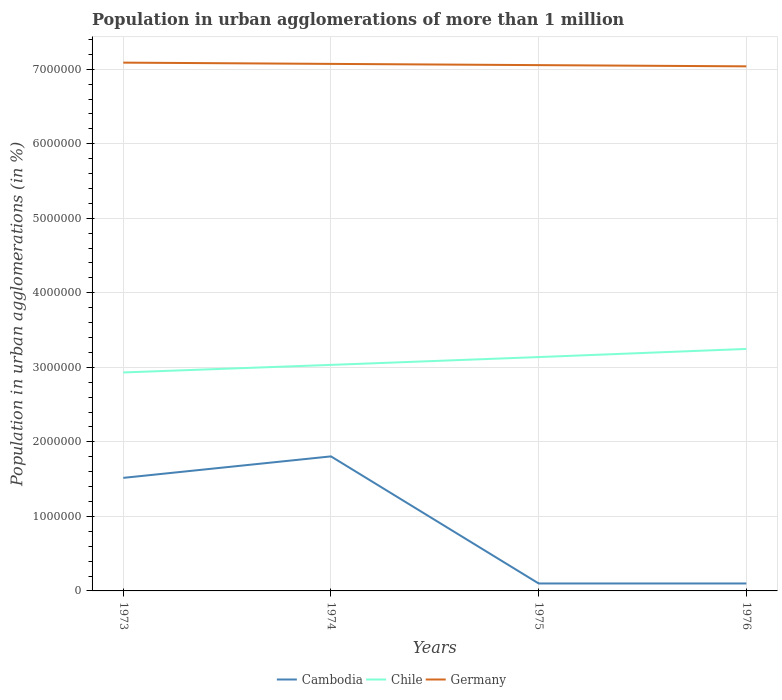How many different coloured lines are there?
Give a very brief answer. 3. Is the number of lines equal to the number of legend labels?
Offer a terse response. Yes. Across all years, what is the maximum population in urban agglomerations in Cambodia?
Your answer should be compact. 1.00e+05. In which year was the population in urban agglomerations in Germany maximum?
Offer a terse response. 1976. What is the total population in urban agglomerations in Germany in the graph?
Make the answer very short. 1.70e+04. What is the difference between the highest and the second highest population in urban agglomerations in Cambodia?
Provide a succinct answer. 1.71e+06. Is the population in urban agglomerations in Cambodia strictly greater than the population in urban agglomerations in Chile over the years?
Provide a short and direct response. Yes. What is the difference between two consecutive major ticks on the Y-axis?
Your answer should be very brief. 1.00e+06. Does the graph contain grids?
Offer a very short reply. Yes. What is the title of the graph?
Your answer should be very brief. Population in urban agglomerations of more than 1 million. What is the label or title of the X-axis?
Offer a terse response. Years. What is the label or title of the Y-axis?
Your response must be concise. Population in urban agglomerations (in %). What is the Population in urban agglomerations (in %) in Cambodia in 1973?
Your answer should be very brief. 1.52e+06. What is the Population in urban agglomerations (in %) of Chile in 1973?
Provide a short and direct response. 2.93e+06. What is the Population in urban agglomerations (in %) in Germany in 1973?
Provide a succinct answer. 7.09e+06. What is the Population in urban agglomerations (in %) of Cambodia in 1974?
Your response must be concise. 1.81e+06. What is the Population in urban agglomerations (in %) in Chile in 1974?
Your response must be concise. 3.03e+06. What is the Population in urban agglomerations (in %) in Germany in 1974?
Offer a very short reply. 7.07e+06. What is the Population in urban agglomerations (in %) in Cambodia in 1975?
Give a very brief answer. 1.00e+05. What is the Population in urban agglomerations (in %) of Chile in 1975?
Provide a short and direct response. 3.14e+06. What is the Population in urban agglomerations (in %) in Germany in 1975?
Keep it short and to the point. 7.05e+06. What is the Population in urban agglomerations (in %) in Cambodia in 1976?
Your answer should be very brief. 1.00e+05. What is the Population in urban agglomerations (in %) in Chile in 1976?
Your answer should be compact. 3.25e+06. What is the Population in urban agglomerations (in %) of Germany in 1976?
Keep it short and to the point. 7.04e+06. Across all years, what is the maximum Population in urban agglomerations (in %) in Cambodia?
Make the answer very short. 1.81e+06. Across all years, what is the maximum Population in urban agglomerations (in %) of Chile?
Give a very brief answer. 3.25e+06. Across all years, what is the maximum Population in urban agglomerations (in %) of Germany?
Make the answer very short. 7.09e+06. Across all years, what is the minimum Population in urban agglomerations (in %) of Chile?
Provide a short and direct response. 2.93e+06. Across all years, what is the minimum Population in urban agglomerations (in %) in Germany?
Your answer should be compact. 7.04e+06. What is the total Population in urban agglomerations (in %) in Cambodia in the graph?
Provide a short and direct response. 3.52e+06. What is the total Population in urban agglomerations (in %) of Chile in the graph?
Make the answer very short. 1.23e+07. What is the total Population in urban agglomerations (in %) of Germany in the graph?
Offer a very short reply. 2.83e+07. What is the difference between the Population in urban agglomerations (in %) of Cambodia in 1973 and that in 1974?
Offer a very short reply. -2.88e+05. What is the difference between the Population in urban agglomerations (in %) of Chile in 1973 and that in 1974?
Offer a terse response. -1.02e+05. What is the difference between the Population in urban agglomerations (in %) of Germany in 1973 and that in 1974?
Offer a terse response. 1.70e+04. What is the difference between the Population in urban agglomerations (in %) in Cambodia in 1973 and that in 1975?
Offer a very short reply. 1.42e+06. What is the difference between the Population in urban agglomerations (in %) in Chile in 1973 and that in 1975?
Offer a very short reply. -2.07e+05. What is the difference between the Population in urban agglomerations (in %) of Germany in 1973 and that in 1975?
Your response must be concise. 3.37e+04. What is the difference between the Population in urban agglomerations (in %) of Cambodia in 1973 and that in 1976?
Keep it short and to the point. 1.42e+06. What is the difference between the Population in urban agglomerations (in %) of Chile in 1973 and that in 1976?
Your answer should be compact. -3.15e+05. What is the difference between the Population in urban agglomerations (in %) of Germany in 1973 and that in 1976?
Your response must be concise. 5.00e+04. What is the difference between the Population in urban agglomerations (in %) in Cambodia in 1974 and that in 1975?
Give a very brief answer. 1.71e+06. What is the difference between the Population in urban agglomerations (in %) in Chile in 1974 and that in 1975?
Make the answer very short. -1.05e+05. What is the difference between the Population in urban agglomerations (in %) in Germany in 1974 and that in 1975?
Offer a terse response. 1.67e+04. What is the difference between the Population in urban agglomerations (in %) of Cambodia in 1974 and that in 1976?
Your response must be concise. 1.71e+06. What is the difference between the Population in urban agglomerations (in %) of Chile in 1974 and that in 1976?
Offer a very short reply. -2.14e+05. What is the difference between the Population in urban agglomerations (in %) in Germany in 1974 and that in 1976?
Your response must be concise. 3.30e+04. What is the difference between the Population in urban agglomerations (in %) of Chile in 1975 and that in 1976?
Provide a short and direct response. -1.09e+05. What is the difference between the Population in urban agglomerations (in %) in Germany in 1975 and that in 1976?
Your answer should be very brief. 1.63e+04. What is the difference between the Population in urban agglomerations (in %) in Cambodia in 1973 and the Population in urban agglomerations (in %) in Chile in 1974?
Your response must be concise. -1.52e+06. What is the difference between the Population in urban agglomerations (in %) in Cambodia in 1973 and the Population in urban agglomerations (in %) in Germany in 1974?
Provide a succinct answer. -5.55e+06. What is the difference between the Population in urban agglomerations (in %) in Chile in 1973 and the Population in urban agglomerations (in %) in Germany in 1974?
Your response must be concise. -4.14e+06. What is the difference between the Population in urban agglomerations (in %) of Cambodia in 1973 and the Population in urban agglomerations (in %) of Chile in 1975?
Your answer should be compact. -1.62e+06. What is the difference between the Population in urban agglomerations (in %) of Cambodia in 1973 and the Population in urban agglomerations (in %) of Germany in 1975?
Keep it short and to the point. -5.54e+06. What is the difference between the Population in urban agglomerations (in %) of Chile in 1973 and the Population in urban agglomerations (in %) of Germany in 1975?
Make the answer very short. -4.12e+06. What is the difference between the Population in urban agglomerations (in %) of Cambodia in 1973 and the Population in urban agglomerations (in %) of Chile in 1976?
Make the answer very short. -1.73e+06. What is the difference between the Population in urban agglomerations (in %) of Cambodia in 1973 and the Population in urban agglomerations (in %) of Germany in 1976?
Make the answer very short. -5.52e+06. What is the difference between the Population in urban agglomerations (in %) of Chile in 1973 and the Population in urban agglomerations (in %) of Germany in 1976?
Keep it short and to the point. -4.11e+06. What is the difference between the Population in urban agglomerations (in %) of Cambodia in 1974 and the Population in urban agglomerations (in %) of Chile in 1975?
Make the answer very short. -1.33e+06. What is the difference between the Population in urban agglomerations (in %) of Cambodia in 1974 and the Population in urban agglomerations (in %) of Germany in 1975?
Your answer should be compact. -5.25e+06. What is the difference between the Population in urban agglomerations (in %) of Chile in 1974 and the Population in urban agglomerations (in %) of Germany in 1975?
Provide a short and direct response. -4.02e+06. What is the difference between the Population in urban agglomerations (in %) of Cambodia in 1974 and the Population in urban agglomerations (in %) of Chile in 1976?
Make the answer very short. -1.44e+06. What is the difference between the Population in urban agglomerations (in %) in Cambodia in 1974 and the Population in urban agglomerations (in %) in Germany in 1976?
Ensure brevity in your answer.  -5.23e+06. What is the difference between the Population in urban agglomerations (in %) in Chile in 1974 and the Population in urban agglomerations (in %) in Germany in 1976?
Your response must be concise. -4.01e+06. What is the difference between the Population in urban agglomerations (in %) in Cambodia in 1975 and the Population in urban agglomerations (in %) in Chile in 1976?
Provide a succinct answer. -3.15e+06. What is the difference between the Population in urban agglomerations (in %) of Cambodia in 1975 and the Population in urban agglomerations (in %) of Germany in 1976?
Keep it short and to the point. -6.94e+06. What is the difference between the Population in urban agglomerations (in %) in Chile in 1975 and the Population in urban agglomerations (in %) in Germany in 1976?
Your answer should be compact. -3.90e+06. What is the average Population in urban agglomerations (in %) in Cambodia per year?
Your response must be concise. 8.81e+05. What is the average Population in urban agglomerations (in %) of Chile per year?
Ensure brevity in your answer.  3.09e+06. What is the average Population in urban agglomerations (in %) of Germany per year?
Give a very brief answer. 7.06e+06. In the year 1973, what is the difference between the Population in urban agglomerations (in %) in Cambodia and Population in urban agglomerations (in %) in Chile?
Make the answer very short. -1.41e+06. In the year 1973, what is the difference between the Population in urban agglomerations (in %) of Cambodia and Population in urban agglomerations (in %) of Germany?
Keep it short and to the point. -5.57e+06. In the year 1973, what is the difference between the Population in urban agglomerations (in %) in Chile and Population in urban agglomerations (in %) in Germany?
Give a very brief answer. -4.16e+06. In the year 1974, what is the difference between the Population in urban agglomerations (in %) in Cambodia and Population in urban agglomerations (in %) in Chile?
Your answer should be compact. -1.23e+06. In the year 1974, what is the difference between the Population in urban agglomerations (in %) in Cambodia and Population in urban agglomerations (in %) in Germany?
Your response must be concise. -5.27e+06. In the year 1974, what is the difference between the Population in urban agglomerations (in %) of Chile and Population in urban agglomerations (in %) of Germany?
Provide a short and direct response. -4.04e+06. In the year 1975, what is the difference between the Population in urban agglomerations (in %) of Cambodia and Population in urban agglomerations (in %) of Chile?
Offer a very short reply. -3.04e+06. In the year 1975, what is the difference between the Population in urban agglomerations (in %) in Cambodia and Population in urban agglomerations (in %) in Germany?
Keep it short and to the point. -6.95e+06. In the year 1975, what is the difference between the Population in urban agglomerations (in %) in Chile and Population in urban agglomerations (in %) in Germany?
Offer a very short reply. -3.92e+06. In the year 1976, what is the difference between the Population in urban agglomerations (in %) in Cambodia and Population in urban agglomerations (in %) in Chile?
Offer a terse response. -3.15e+06. In the year 1976, what is the difference between the Population in urban agglomerations (in %) in Cambodia and Population in urban agglomerations (in %) in Germany?
Ensure brevity in your answer.  -6.94e+06. In the year 1976, what is the difference between the Population in urban agglomerations (in %) of Chile and Population in urban agglomerations (in %) of Germany?
Provide a succinct answer. -3.79e+06. What is the ratio of the Population in urban agglomerations (in %) in Cambodia in 1973 to that in 1974?
Offer a very short reply. 0.84. What is the ratio of the Population in urban agglomerations (in %) of Chile in 1973 to that in 1974?
Ensure brevity in your answer.  0.97. What is the ratio of the Population in urban agglomerations (in %) in Cambodia in 1973 to that in 1975?
Make the answer very short. 15.17. What is the ratio of the Population in urban agglomerations (in %) in Chile in 1973 to that in 1975?
Offer a terse response. 0.93. What is the ratio of the Population in urban agglomerations (in %) in Cambodia in 1973 to that in 1976?
Your response must be concise. 15.17. What is the ratio of the Population in urban agglomerations (in %) in Chile in 1973 to that in 1976?
Your answer should be compact. 0.9. What is the ratio of the Population in urban agglomerations (in %) of Germany in 1973 to that in 1976?
Your answer should be compact. 1.01. What is the ratio of the Population in urban agglomerations (in %) of Cambodia in 1974 to that in 1975?
Give a very brief answer. 18.05. What is the ratio of the Population in urban agglomerations (in %) in Chile in 1974 to that in 1975?
Offer a very short reply. 0.97. What is the ratio of the Population in urban agglomerations (in %) in Germany in 1974 to that in 1975?
Keep it short and to the point. 1. What is the ratio of the Population in urban agglomerations (in %) in Cambodia in 1974 to that in 1976?
Offer a very short reply. 18.05. What is the ratio of the Population in urban agglomerations (in %) in Chile in 1974 to that in 1976?
Your answer should be compact. 0.93. What is the ratio of the Population in urban agglomerations (in %) in Germany in 1974 to that in 1976?
Your answer should be compact. 1. What is the ratio of the Population in urban agglomerations (in %) of Chile in 1975 to that in 1976?
Keep it short and to the point. 0.97. What is the difference between the highest and the second highest Population in urban agglomerations (in %) of Cambodia?
Your answer should be compact. 2.88e+05. What is the difference between the highest and the second highest Population in urban agglomerations (in %) in Chile?
Your response must be concise. 1.09e+05. What is the difference between the highest and the second highest Population in urban agglomerations (in %) in Germany?
Keep it short and to the point. 1.70e+04. What is the difference between the highest and the lowest Population in urban agglomerations (in %) in Cambodia?
Provide a short and direct response. 1.71e+06. What is the difference between the highest and the lowest Population in urban agglomerations (in %) in Chile?
Offer a terse response. 3.15e+05. What is the difference between the highest and the lowest Population in urban agglomerations (in %) of Germany?
Your answer should be very brief. 5.00e+04. 